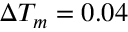<formula> <loc_0><loc_0><loc_500><loc_500>\Delta T _ { m } = 0 . 0 4</formula> 